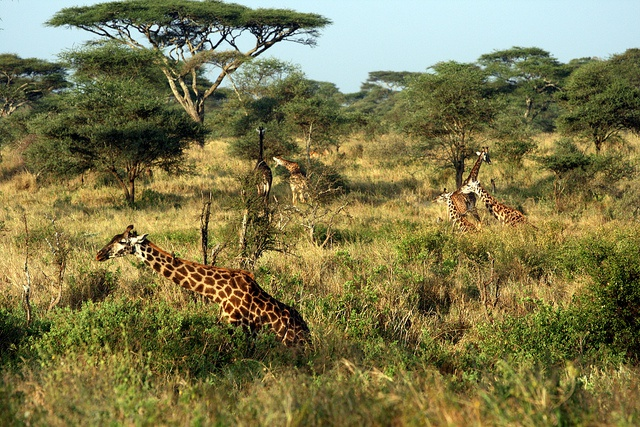Describe the objects in this image and their specific colors. I can see giraffe in lightblue, black, maroon, brown, and tan tones, giraffe in lightblue, tan, brown, khaki, and maroon tones, giraffe in lightblue, olive, black, and tan tones, giraffe in lightblue, black, olive, maroon, and tan tones, and giraffe in lightblue, olive, and tan tones in this image. 